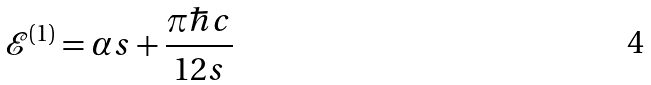<formula> <loc_0><loc_0><loc_500><loc_500>\mathcal { E } ^ { ( 1 ) } = \alpha s + \frac { \pi \hbar { c } } { 1 2 s }</formula> 